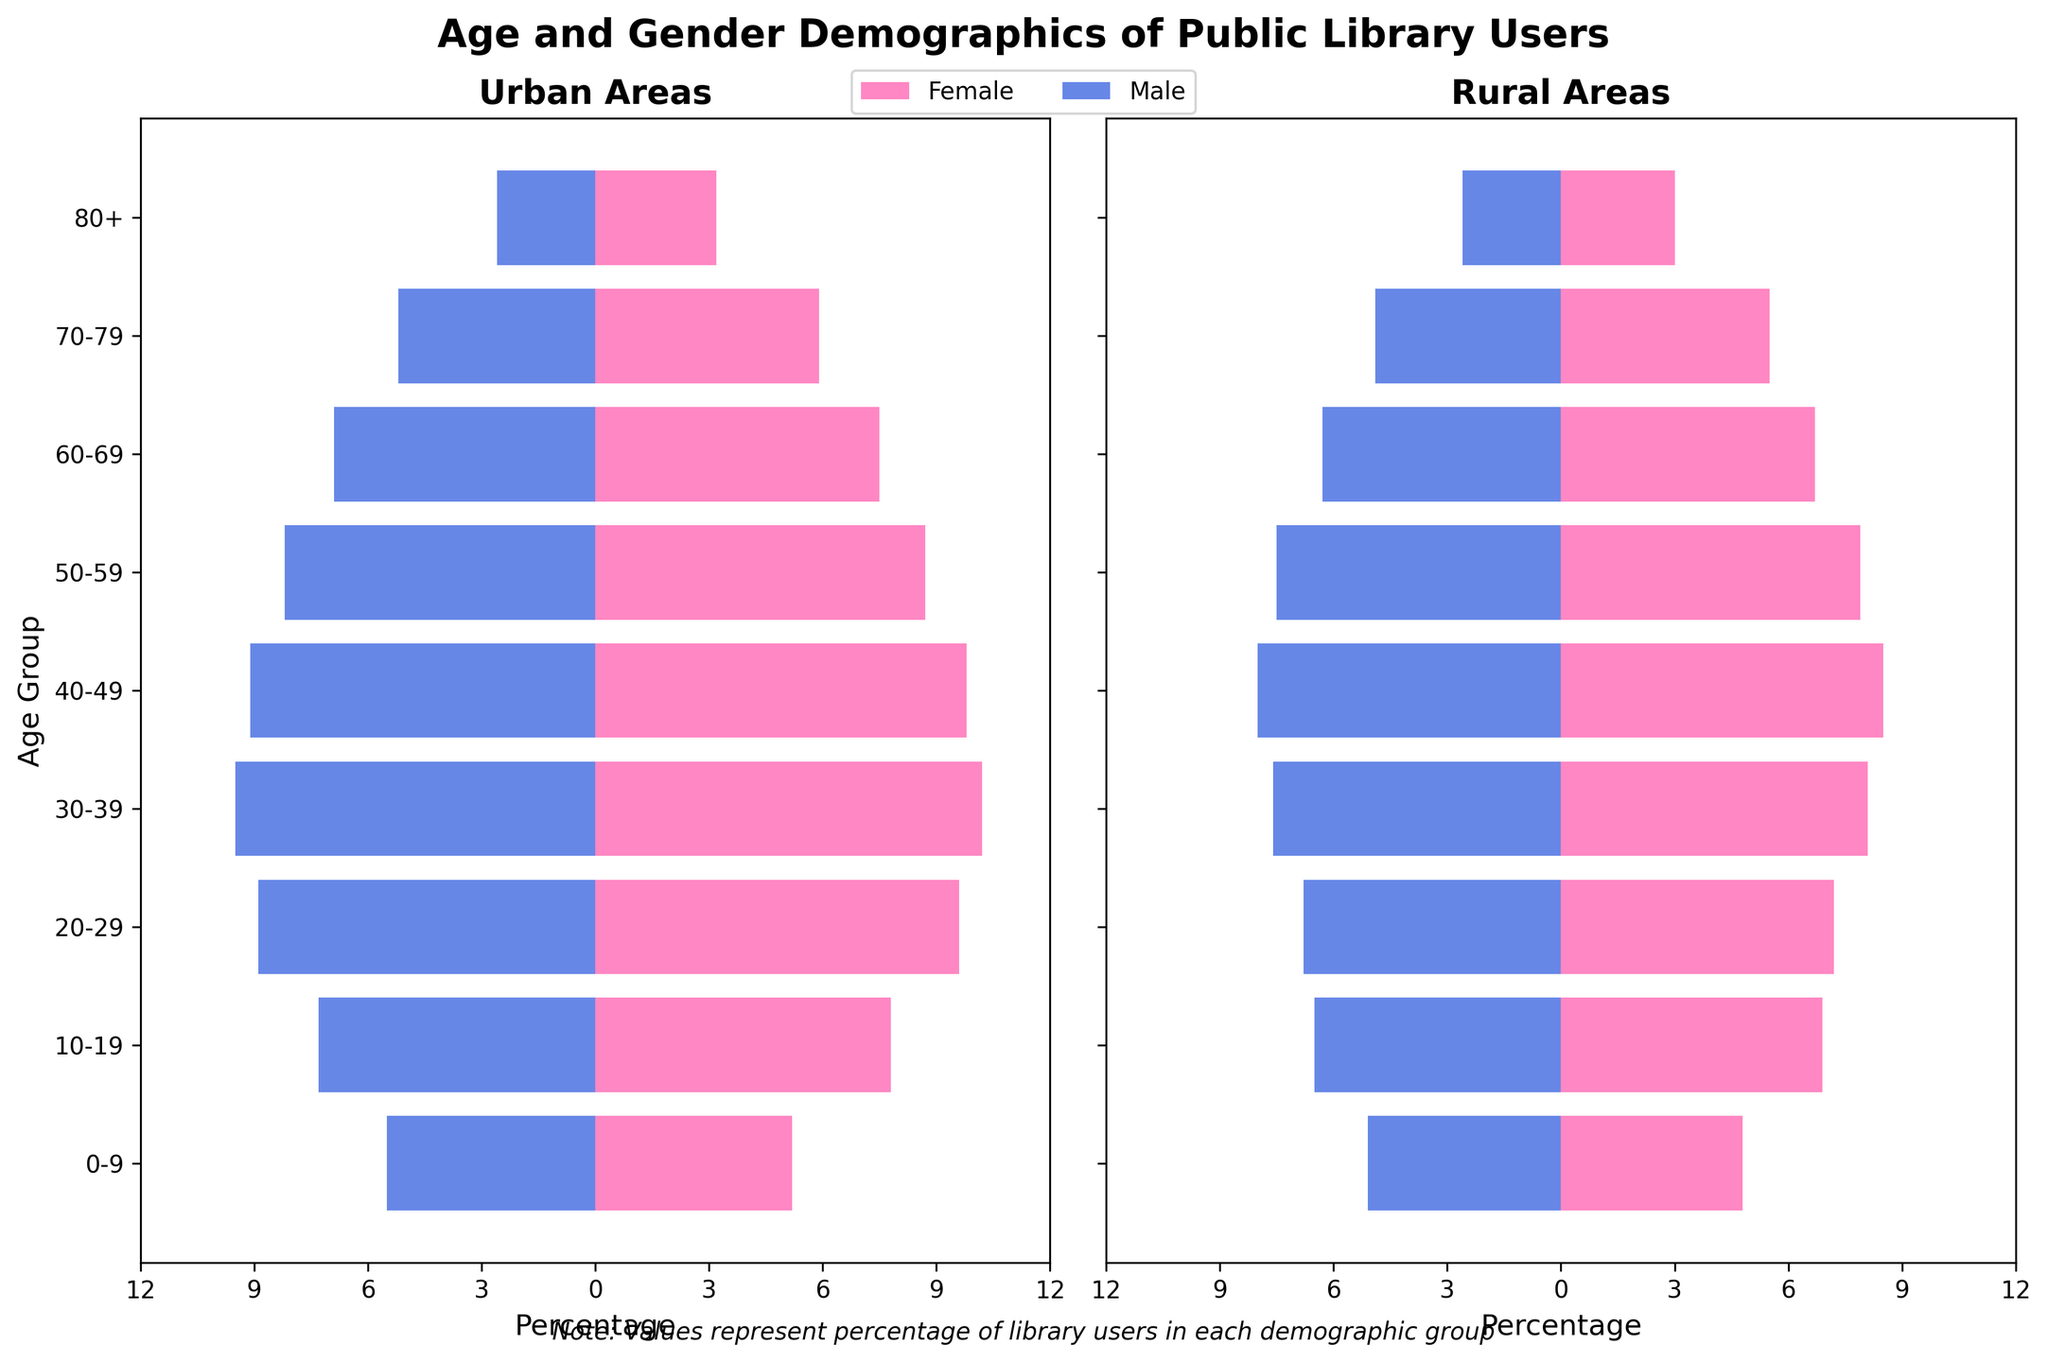What title does the figure have? The figure has a title section at the top that declares the topic being visualized. The specific text used for the title is visible at the top of the figure's layout.
Answer: Age and Gender Demographics of Public Library Users How many age groups are represented in the figure? The Y-axis of the figure represents the age groups. Counting all distinct age group labels along the Y-axis gives the total number.
Answer: 9 Which age group has the highest percentage of urban female library users? To determine the age group with the highest percentage, you need to check all the urban female bars and find the longest one. The 30-39 age group's bar is the longest among the urban females.
Answer: 30-39 Which gender and area combination shows a higher percentage of library users aged 70-79? Compare the percentages represented by the bars (both positive for females and negative for males) in the 70-79 age group for urban and rural areas. Among urban female (5.9), urban male (-5.2), rural female (5.5), and rural male (-4.9), urban female is the highest.
Answer: Urban Female In which area do males aged 60-69 represent a larger percentage of library users? Compare the lengths (in the negative direction) of the bars representing males aged 60-69 for both urban and rural areas. The urban male bar (-6.9) is longer than the rural male bar (-6.3).
Answer: Urban What trend do you observe in the percentages of urban female library users from age group 0-9 to 50-59? Note the progression of the bar lengths for urban females from the age group 0-9 (5.2) to 50-59 (8.7) and observe any increase or decrease. The percentages tend to increase initially and then start to decline after peaking around age 30-39 (10.2).
Answer: Increasing initially, then decreasing after 30-39 How do the percentages of rural female users in the 40-49 age group compare to those in the 30-39 age group? Observe the length of the bars for rural females in both the 30-39 (8.1) and 40-49 (8.5) age groups. The bar for 40-49 is longer, indicating a higher percentage.
Answer: Higher in 40-49 Which population (urban or rural) has a higher total percentage of users in the 10-19 age group across both genders? Calculate the sum of the percentages for both genders in the 10-19 age group for urban (7.8 + 7.3) and rural areas (6.9 + 6.5). Compare the two sums: 7.8 + 7.3 = 15.1 for urban and 6.9 + 6.5 = 13.4 for rural. The urban area sum is higher.
Answer: Urban 